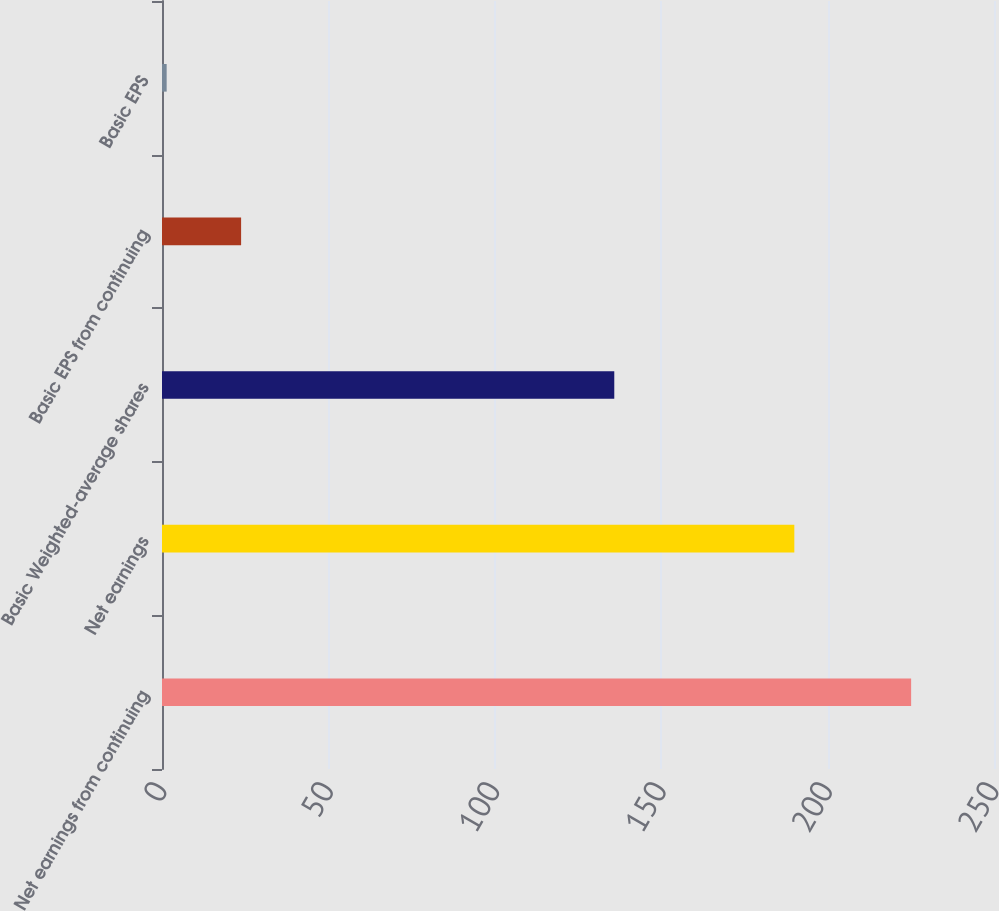Convert chart to OTSL. <chart><loc_0><loc_0><loc_500><loc_500><bar_chart><fcel>Net earnings from continuing<fcel>Net earnings<fcel>Basic Weighted-average shares<fcel>Basic EPS from continuing<fcel>Basic EPS<nl><fcel>225.1<fcel>190<fcel>135.9<fcel>23.77<fcel>1.4<nl></chart> 